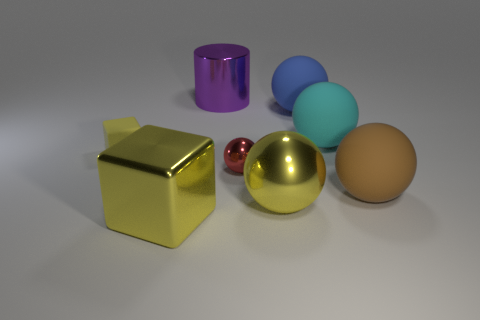There is a block that is in front of the rubber block; is its size the same as the yellow sphere?
Keep it short and to the point. Yes. There is a cube in front of the yellow cube that is behind the brown rubber sphere; what is its size?
Keep it short and to the point. Large. Is the brown thing made of the same material as the large object that is on the left side of the large purple cylinder?
Offer a very short reply. No. Is the number of small matte things in front of the red object less than the number of rubber objects that are on the left side of the metal cylinder?
Your answer should be compact. Yes. What color is the small object that is the same material as the big cylinder?
Ensure brevity in your answer.  Red. Is there a large brown matte thing in front of the yellow cube in front of the brown rubber ball?
Provide a short and direct response. No. The block that is the same size as the brown sphere is what color?
Your answer should be very brief. Yellow. What number of objects are either small blocks or small metal cylinders?
Offer a very short reply. 1. How big is the object on the left side of the block that is to the right of the yellow matte block that is left of the big cyan matte thing?
Provide a succinct answer. Small. What number of tiny matte things are the same color as the big block?
Offer a terse response. 1. 